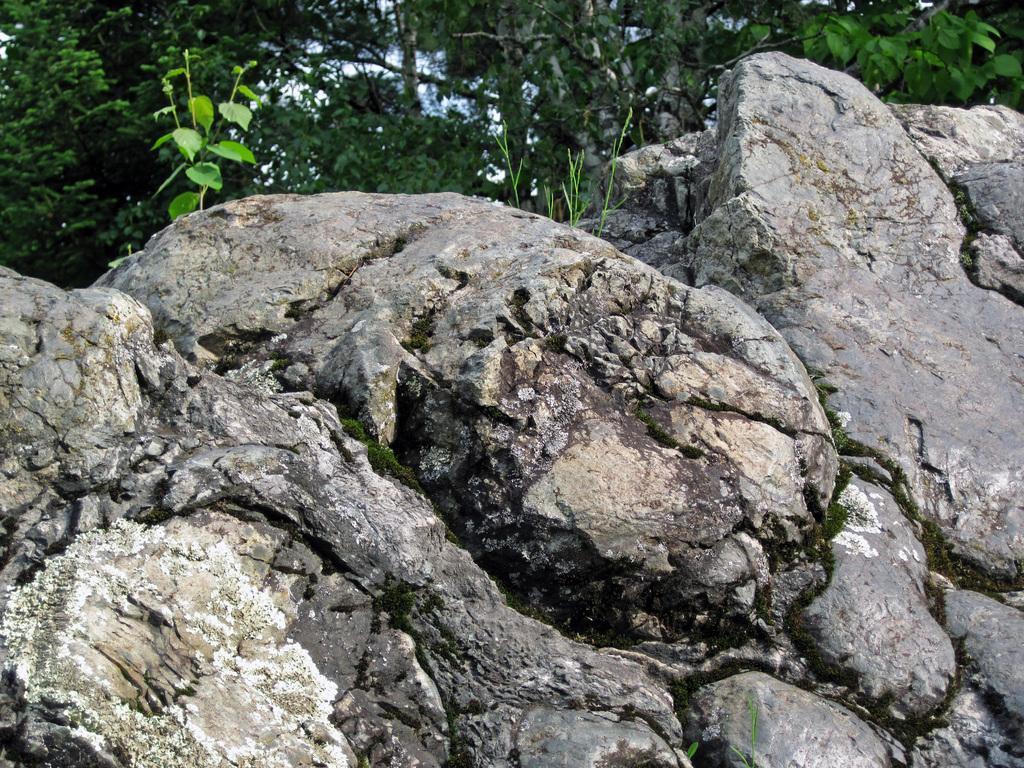Could you give a brief overview of what you see in this image? In this picture we can see a few rocks, plant and trees in the background. 